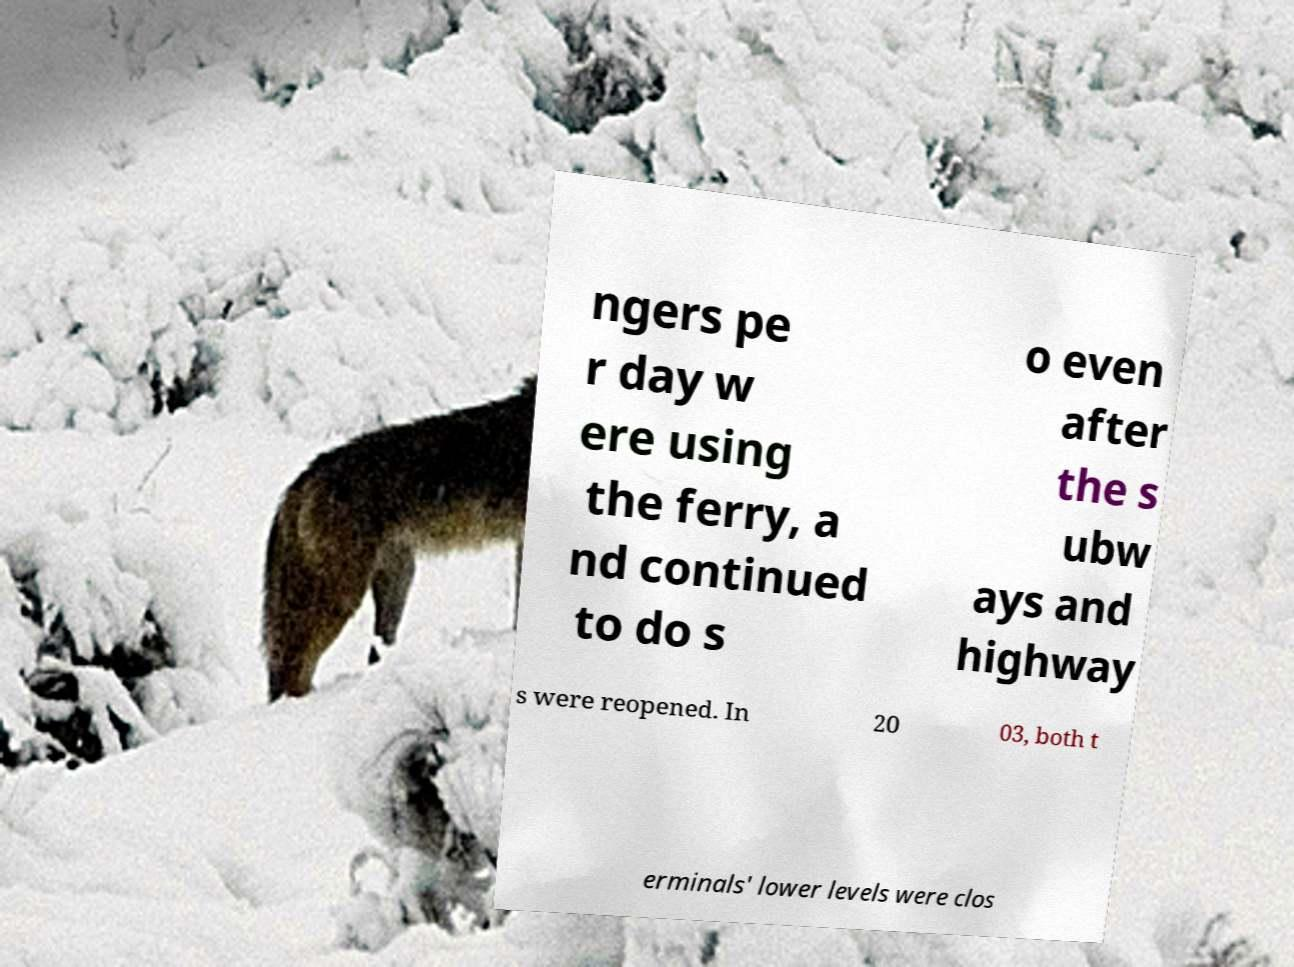Can you accurately transcribe the text from the provided image for me? ngers pe r day w ere using the ferry, a nd continued to do s o even after the s ubw ays and highway s were reopened. In 20 03, both t erminals' lower levels were clos 